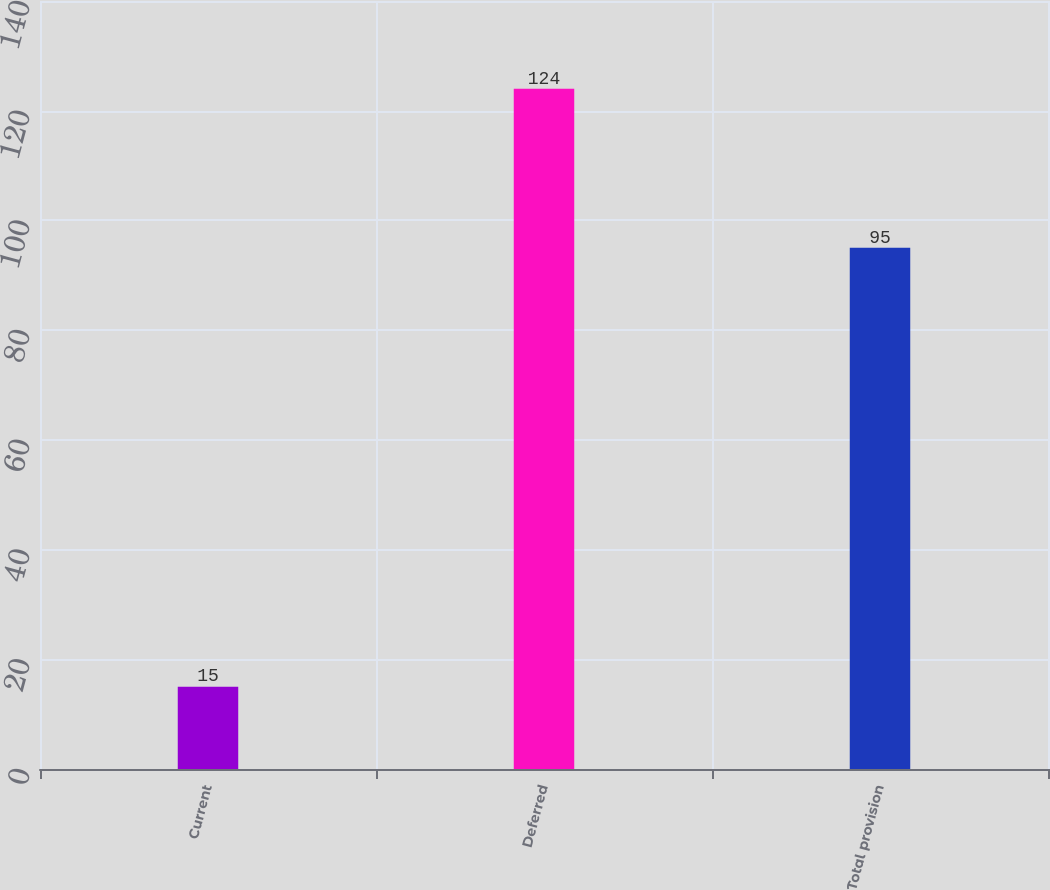<chart> <loc_0><loc_0><loc_500><loc_500><bar_chart><fcel>Current<fcel>Deferred<fcel>Total provision<nl><fcel>15<fcel>124<fcel>95<nl></chart> 